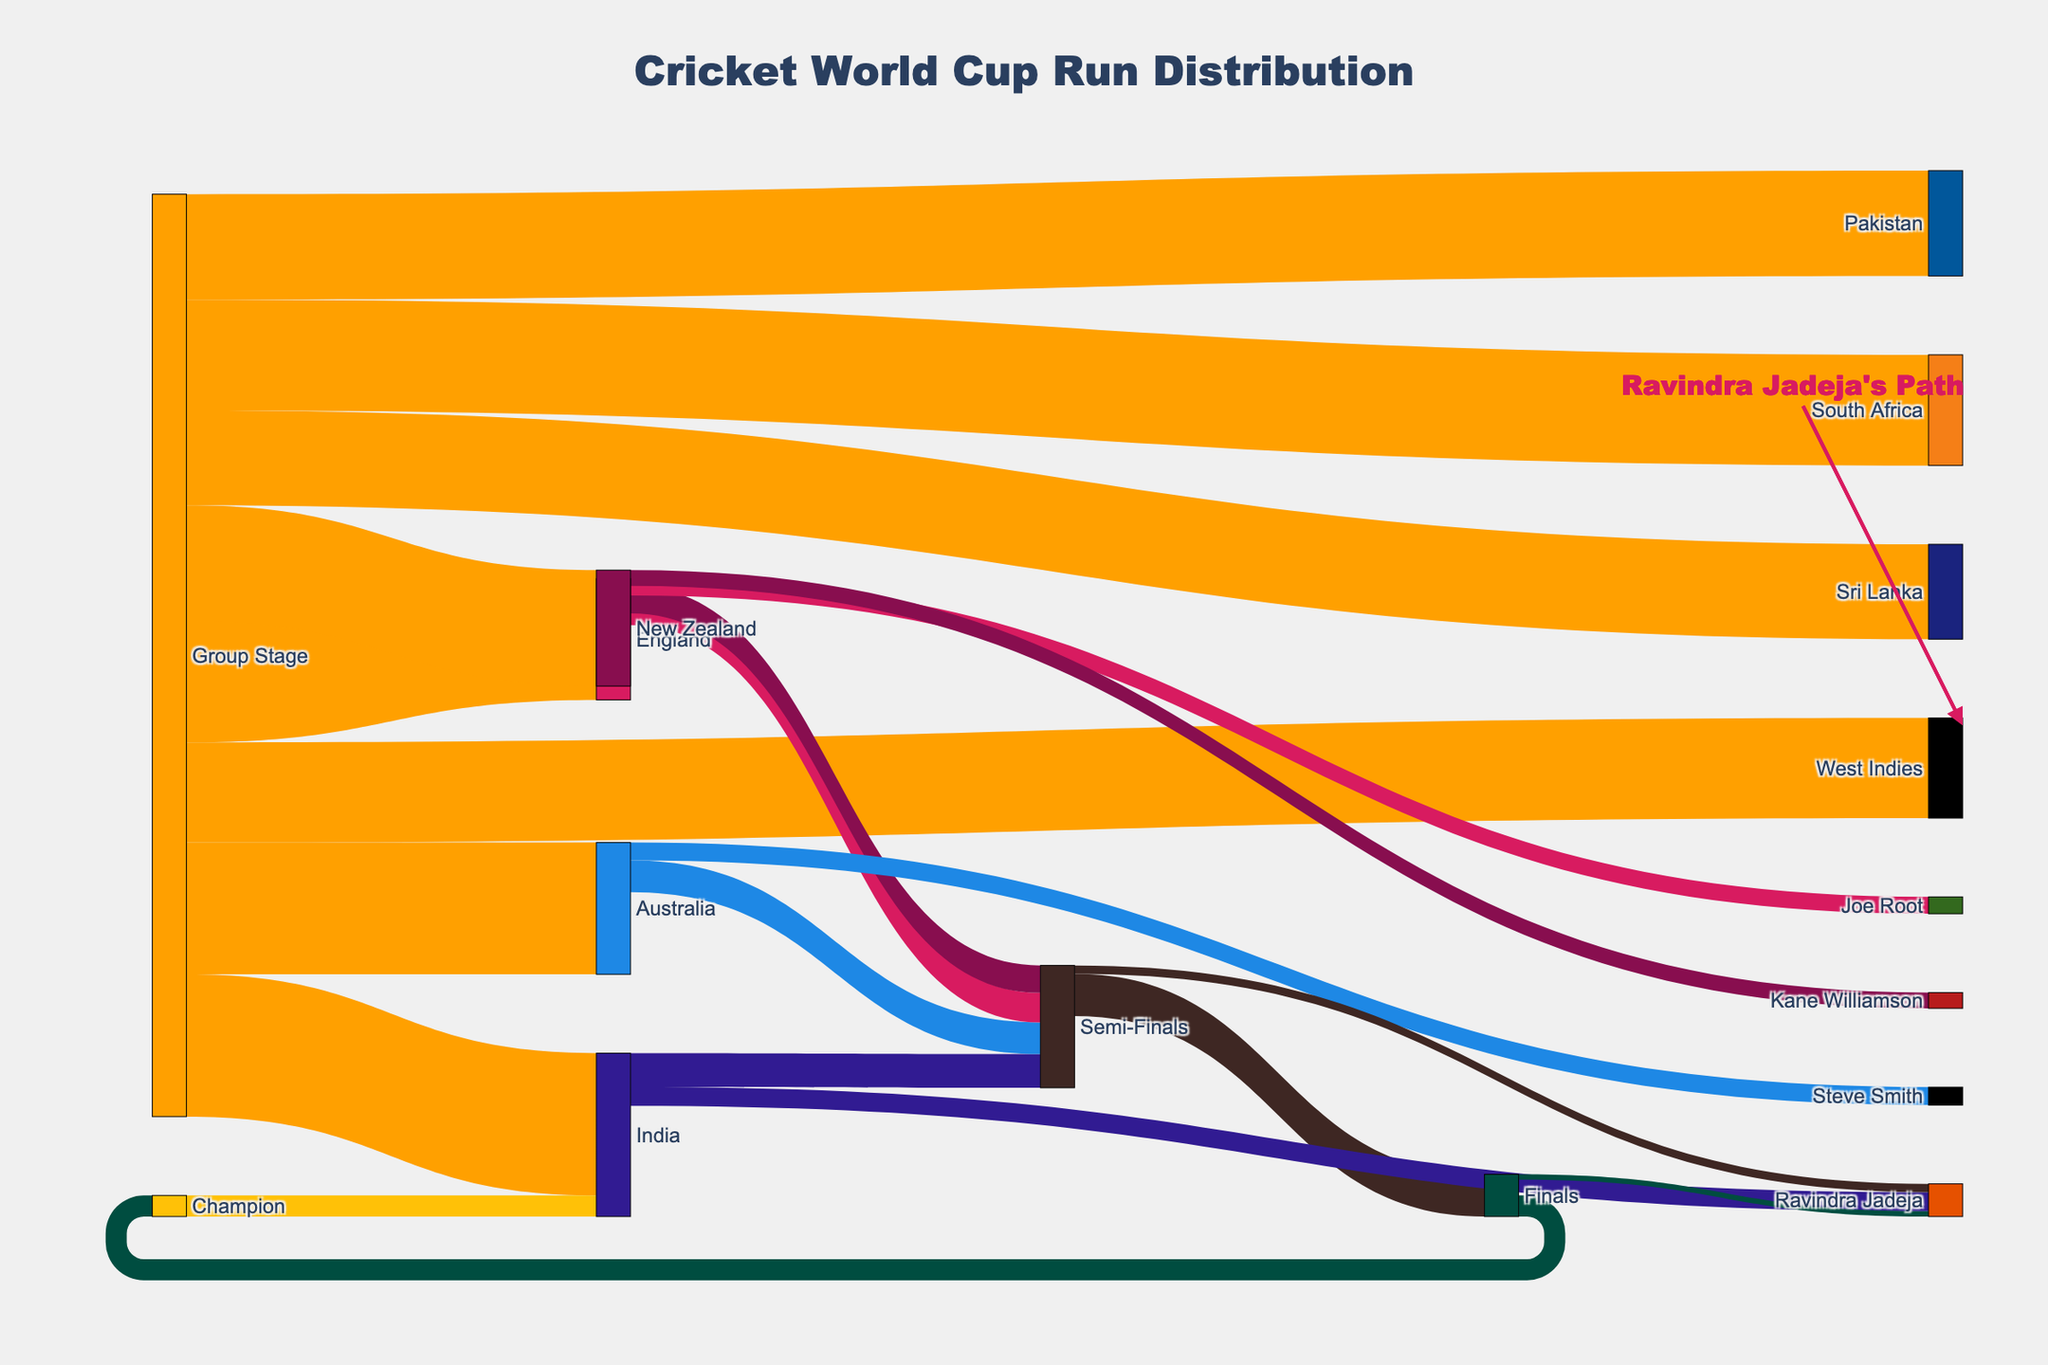What is the total number of runs scored by India during the Group Stage? Look at the value flowing from "Group Stage" to "India," which is 1350.
Answer: 1350 Which team scored the highest runs in the Group Stage? Check the values flowing from "Group Stage" to each team: India (1350), Australia (1250), England (1150), and so on. India scored the highest.
Answer: India How many runs did Ravindra Jadeja score in the Semi-Finals? Identify the segment leading to "Ravindra Jadeja" from "Semi-Finals," which shows 80 runs.
Answer: 80 Compare the total runs scored by India and Australia in the Group Stage. Which team scored more? Compare the values from "Group Stage" to "India" (1350) and "Australia" (1250). India scored more.
Answer: India What is the total runs scored by Ravindra Jadeja throughout the World Cup? Add up the values leading to "Ravindra Jadeja": from "India" (180), from "Semi-Finals" (80), and from "Finals" (50). 180 + 80 + 50 = 310.
Answer: 310 Which phase contributes the largest number of runs to the Champion team, India? Trace the values flowing to "Champion" from "Finals" (200 runs). Since there is only one phase directly leading to "Champion" ("Finals"), it's the only contributor.
Answer: Finals What is the combined total runs of England and New Zealand in the Group Stage? Add the values from "Group Stage" to England (1150) and New Zealand (1100). 1150 + 1100 = 2250.
Answer: 2250 How many runs did India score in the Finals? Identify the segment leading to "Finals" from "India," showing 200 runs.
Answer: 200 Which player from the listed ones scored the least runs? Compare the values leading to the players: Ravindra Jadeja (180 from India, 80 from Semi-Finals, 50 from Finals), Steve Smith (170), Joe Root (160), and Kane Williamson (150). Kane Williamson scored the least.
Answer: Kane Williamson What are the total runs scored in the Semi-Finals stage? Add up the runs leading to "Semi-Finals": from India (320), Australia (300), England (280), and New Zealand (260). 320 + 300 + 280 + 260 = 1160.
Answer: 1160 